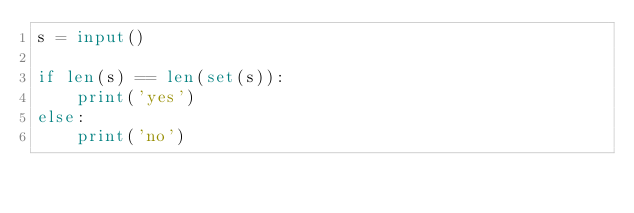<code> <loc_0><loc_0><loc_500><loc_500><_Python_>s = input()

if len(s) == len(set(s)):
    print('yes')
else:
    print('no')</code> 